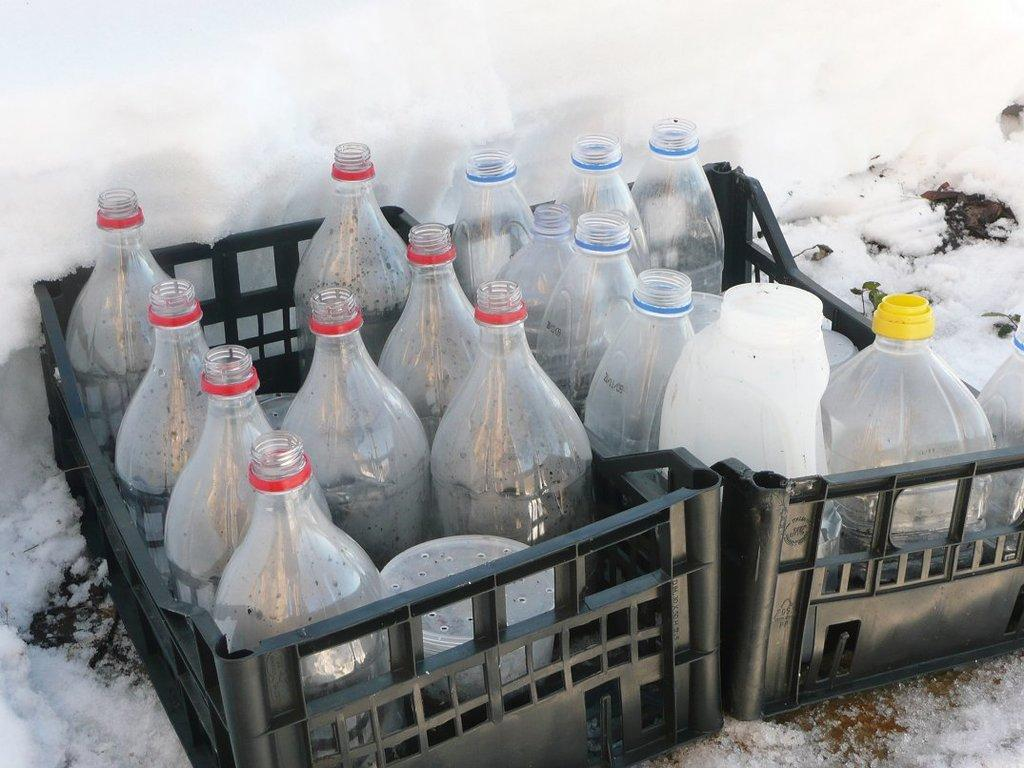What objects can be seen in the image? There are bottles in the image. How are the bottles stored or organized? The bottles are in containers. What can be observed in the background of the image? There is snow in the background of the image. What type of drum can be heard playing in the background of the image? There is no drum or sound present in the image; it only features bottles in containers and snow in the background. 